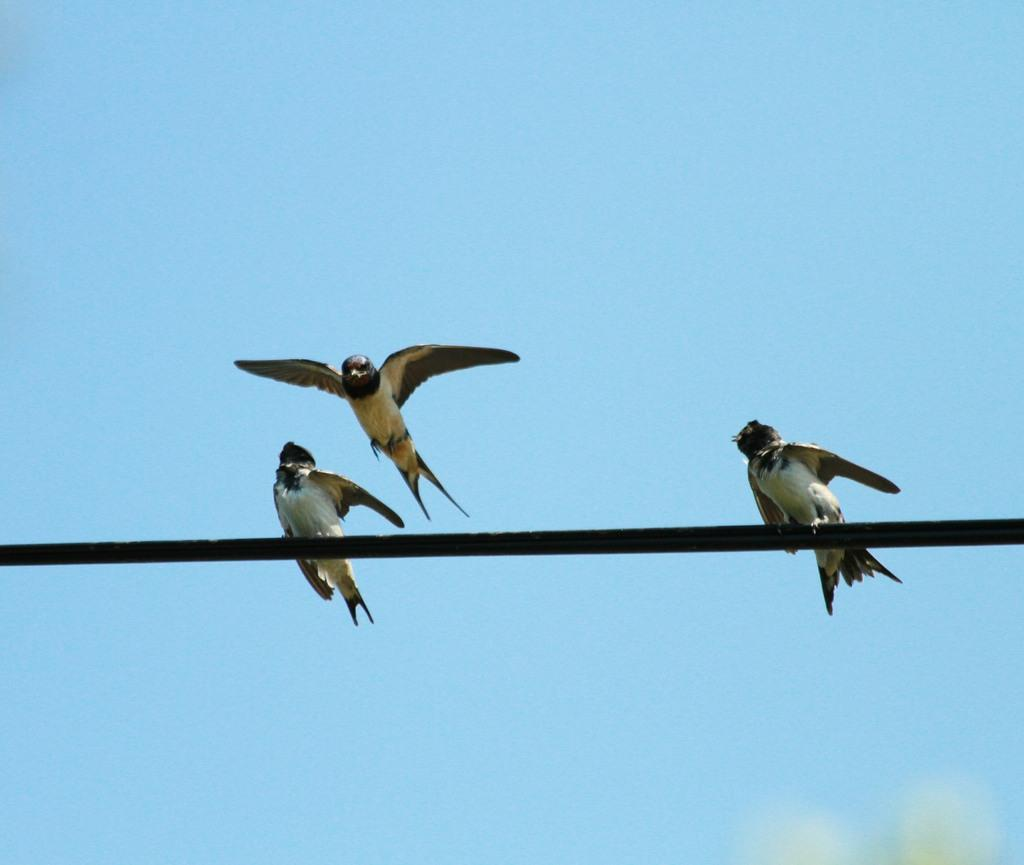What is the main subject of the image? The main subject of the image is two birds on a stick. What is one of the birds doing in the image? One bird is flying in the image. What can be seen in the background of the image? The sky is visible in the background of the image. What type of sweater is the bird wearing in the image? There is no bird wearing a sweater in the image; the birds are not dressed in any clothing. 